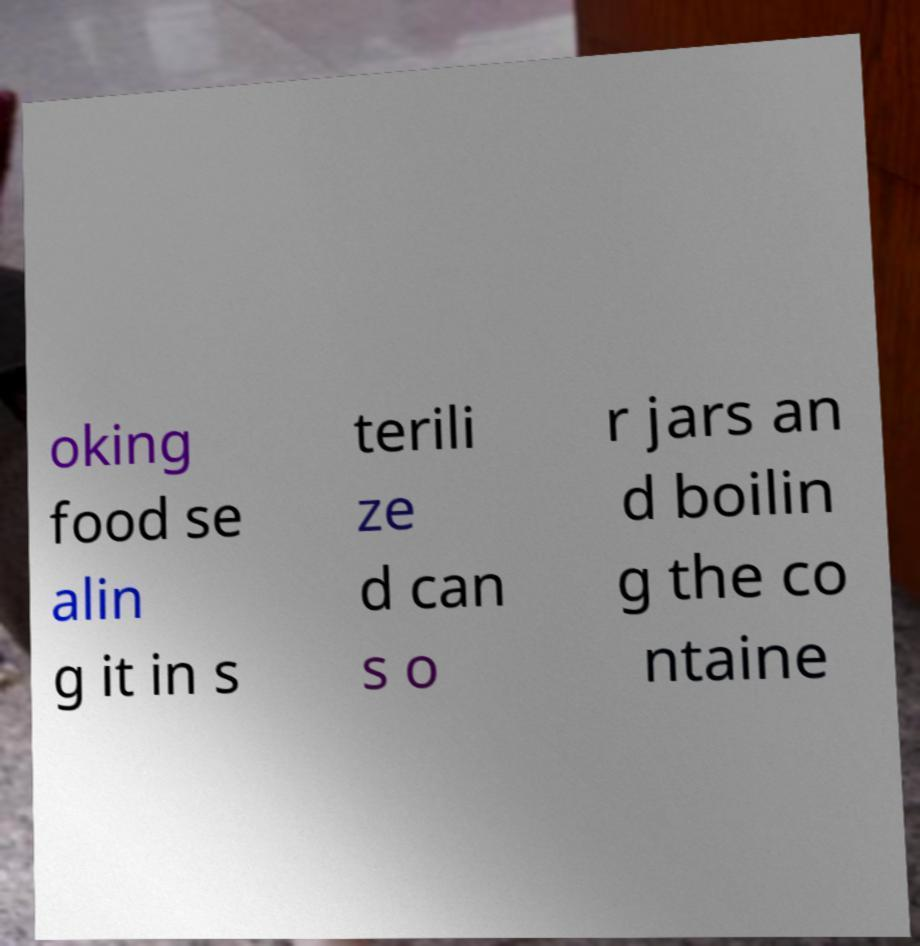There's text embedded in this image that I need extracted. Can you transcribe it verbatim? oking food se alin g it in s terili ze d can s o r jars an d boilin g the co ntaine 